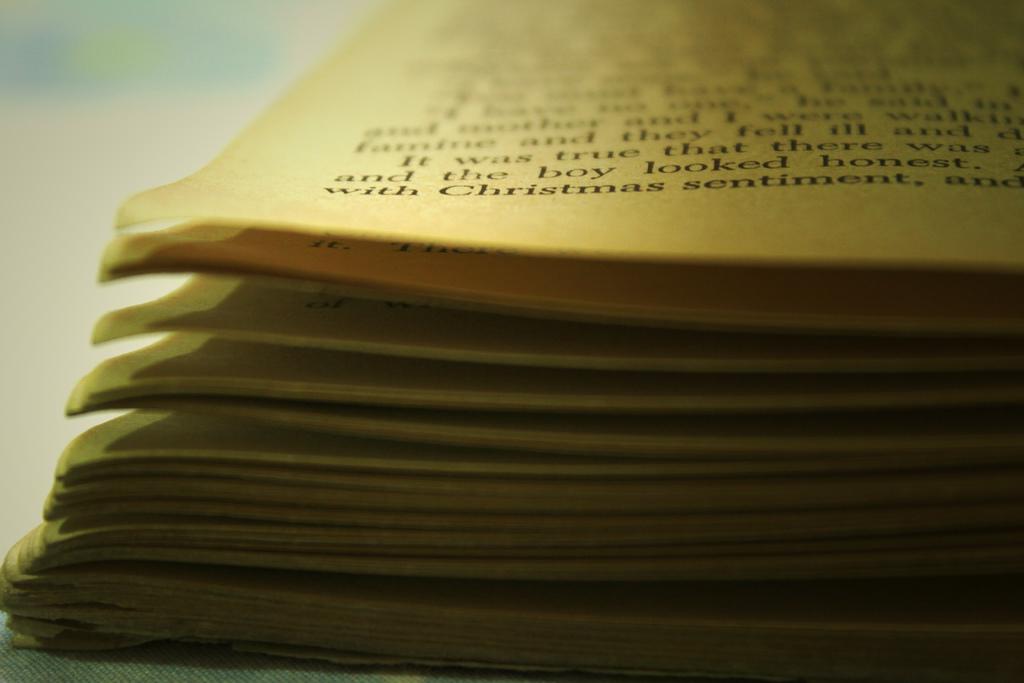What is the word after christmas?
Offer a terse response. Sentiment. 